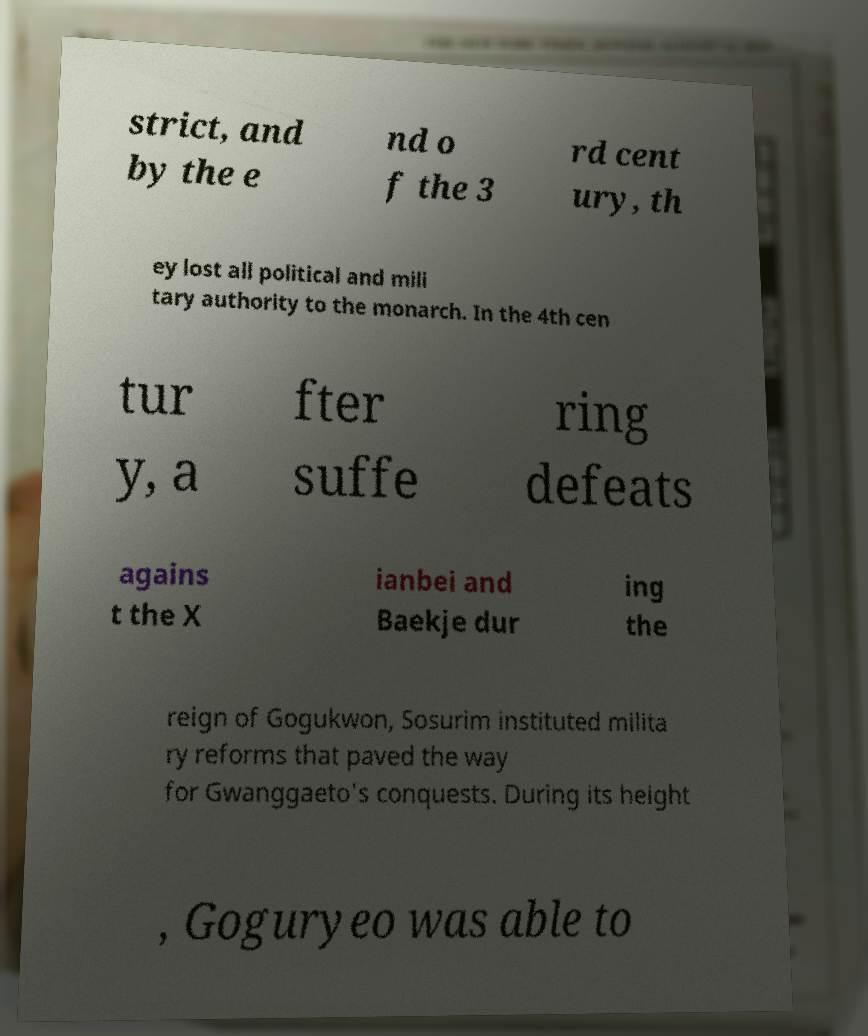Could you extract and type out the text from this image? strict, and by the e nd o f the 3 rd cent ury, th ey lost all political and mili tary authority to the monarch. In the 4th cen tur y, a fter suffe ring defeats agains t the X ianbei and Baekje dur ing the reign of Gogukwon, Sosurim instituted milita ry reforms that paved the way for Gwanggaeto's conquests. During its height , Goguryeo was able to 